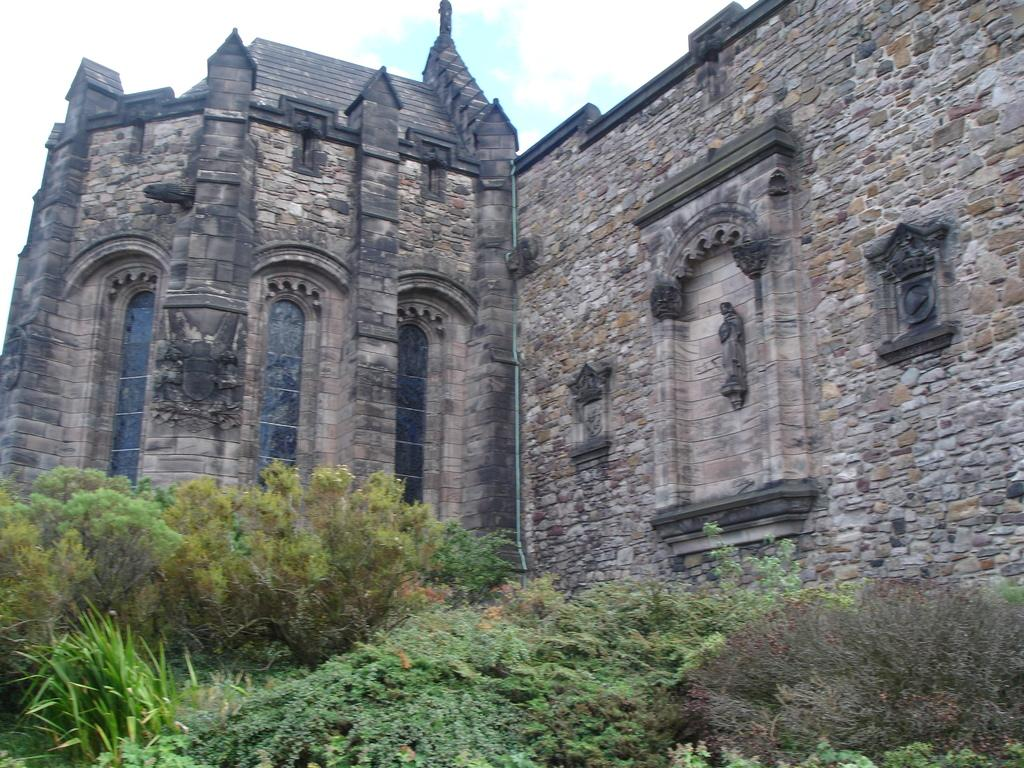What is the main subject in the middle of the image? There is a building in the middle of the image. What type of vegetation is present at the bottom of the image? There are trees at the bottom of the image. What is visible at the top of the image? The sky is visible at the top of the image. What type of card is being used by the authority figure in the image? There is no authority figure or card present in the image. What type of writing can be seen on the building in the image? The facts provided do not mention any writing on the building, so we cannot determine if there is any writing present. 